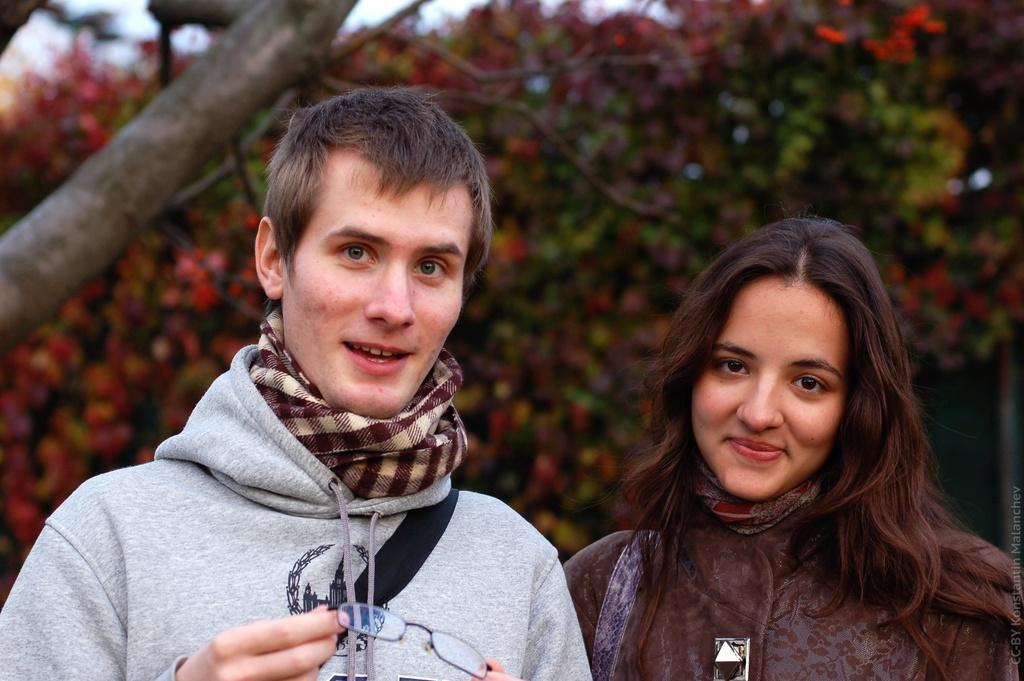Who are the people in the image? There is a man and a lady in the image. What can be observed about the background of the image? The background of the image is blurred. What is the purpose of the chain in the image? There is no chain present in the image. 